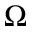Convert formula to latex. <formula><loc_0><loc_0><loc_500><loc_500>\Omega</formula> 